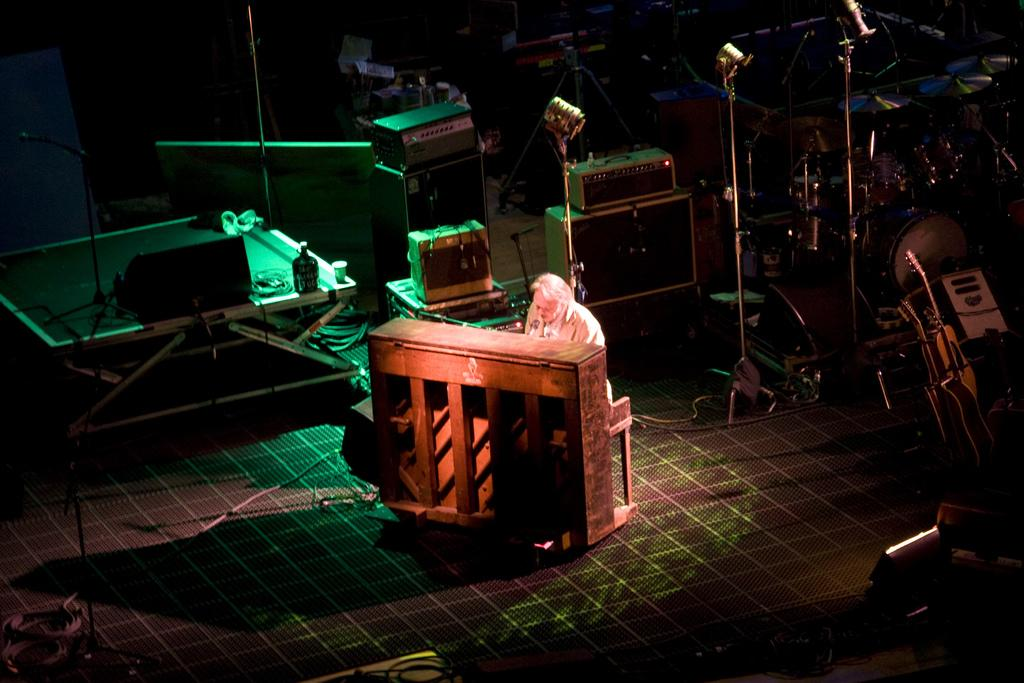What is the main subject of the image? There is a person in the image. What objects are present in the image besides the person? There is a wooden box, speakers, stands, musical instruments, wires, and objects on the floor in the image. What type of objects are the musical instruments? The specific type of musical instruments is not mentioned, but they are present in the image. What is the lighting condition in the image? The image is dark. What direction is the person facing in the image? The direction the person is facing is not mentioned in the facts, so it cannot be determined from the image. What reason does the person have for being in the image? The reason the person is in the image is not mentioned in the facts, so it cannot be determined from the image. What type of shoe is the person wearing in the image? The type of shoe the person is wearing is not mentioned in the facts, so it cannot be determined from the image. 